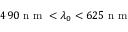<formula> <loc_0><loc_0><loc_500><loc_500>4 9 0 n m < \lambda _ { 0 } < 6 2 5 n m</formula> 